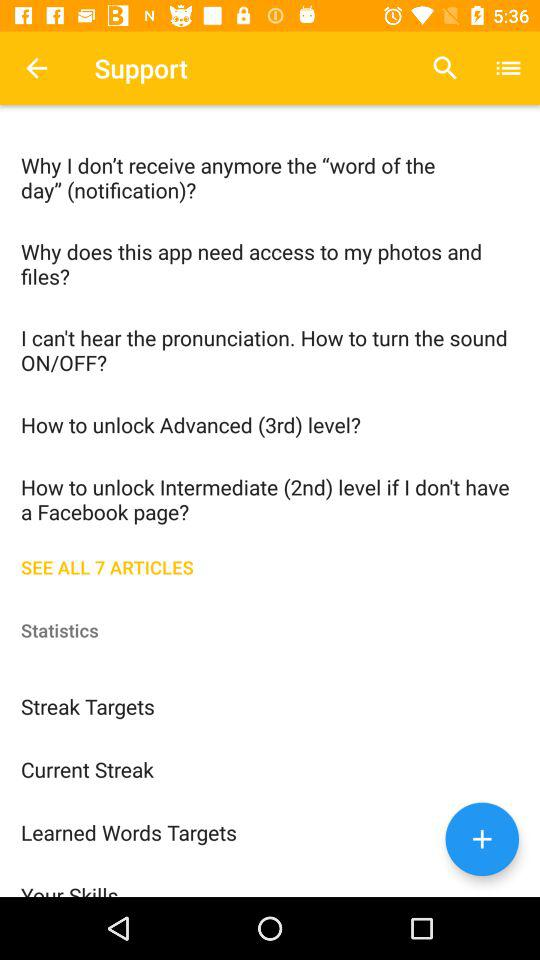What's the total number of articles? The total number of articles is 7. 